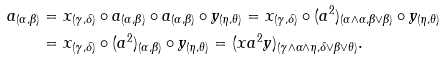Convert formula to latex. <formula><loc_0><loc_0><loc_500><loc_500>a _ { ( \alpha , \beta ) } & = x _ { ( \gamma , \delta ) } \circ a _ { ( \alpha , \beta ) } \circ a _ { ( \alpha , \beta ) } \circ y _ { ( \eta , \theta ) } = x _ { ( \gamma , \delta ) } \circ ( a ^ { 2 } ) _ { ( \alpha \wedge \alpha , \beta \vee \beta ) } \circ y _ { ( \eta , \theta ) } \\ & = x _ { ( \gamma , \delta ) } \circ ( a ^ { 2 } ) _ { ( \alpha , \beta ) } \circ y _ { ( \eta , \theta ) } = ( x a ^ { 2 } y ) _ { ( \gamma \wedge \alpha \wedge \eta , \delta \vee \beta \vee \theta ) } .</formula> 